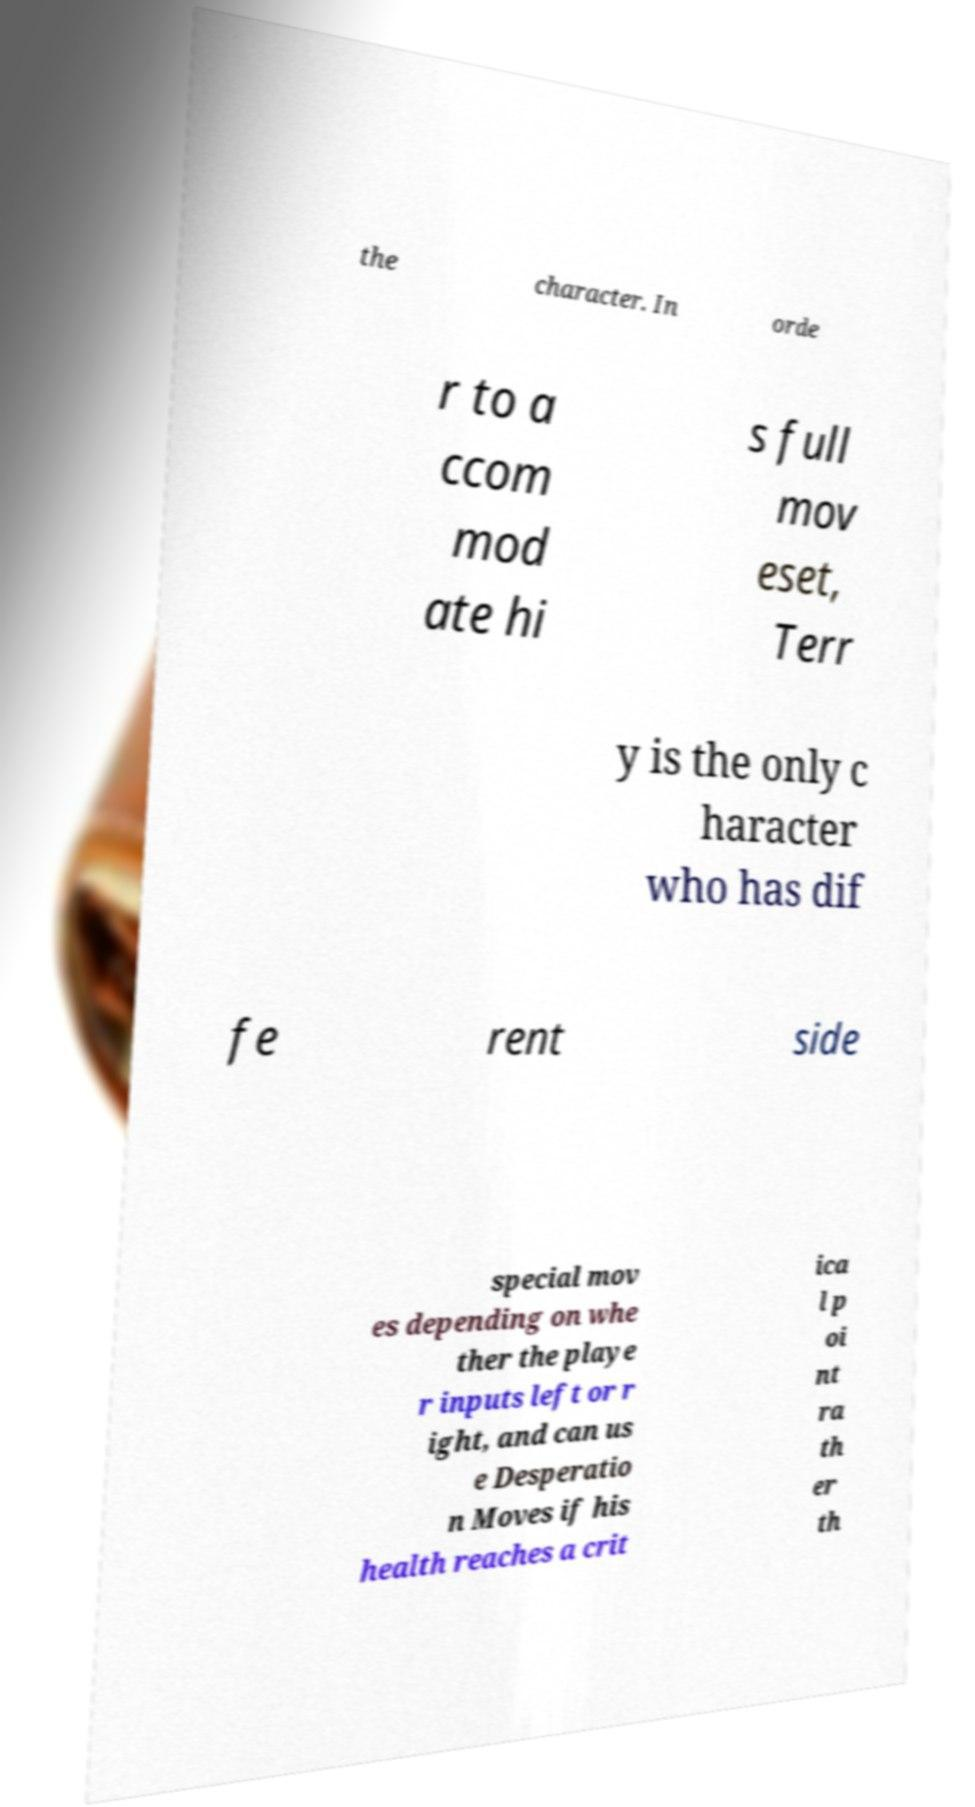Can you accurately transcribe the text from the provided image for me? the character. In orde r to a ccom mod ate hi s full mov eset, Terr y is the only c haracter who has dif fe rent side special mov es depending on whe ther the playe r inputs left or r ight, and can us e Desperatio n Moves if his health reaches a crit ica l p oi nt ra th er th 